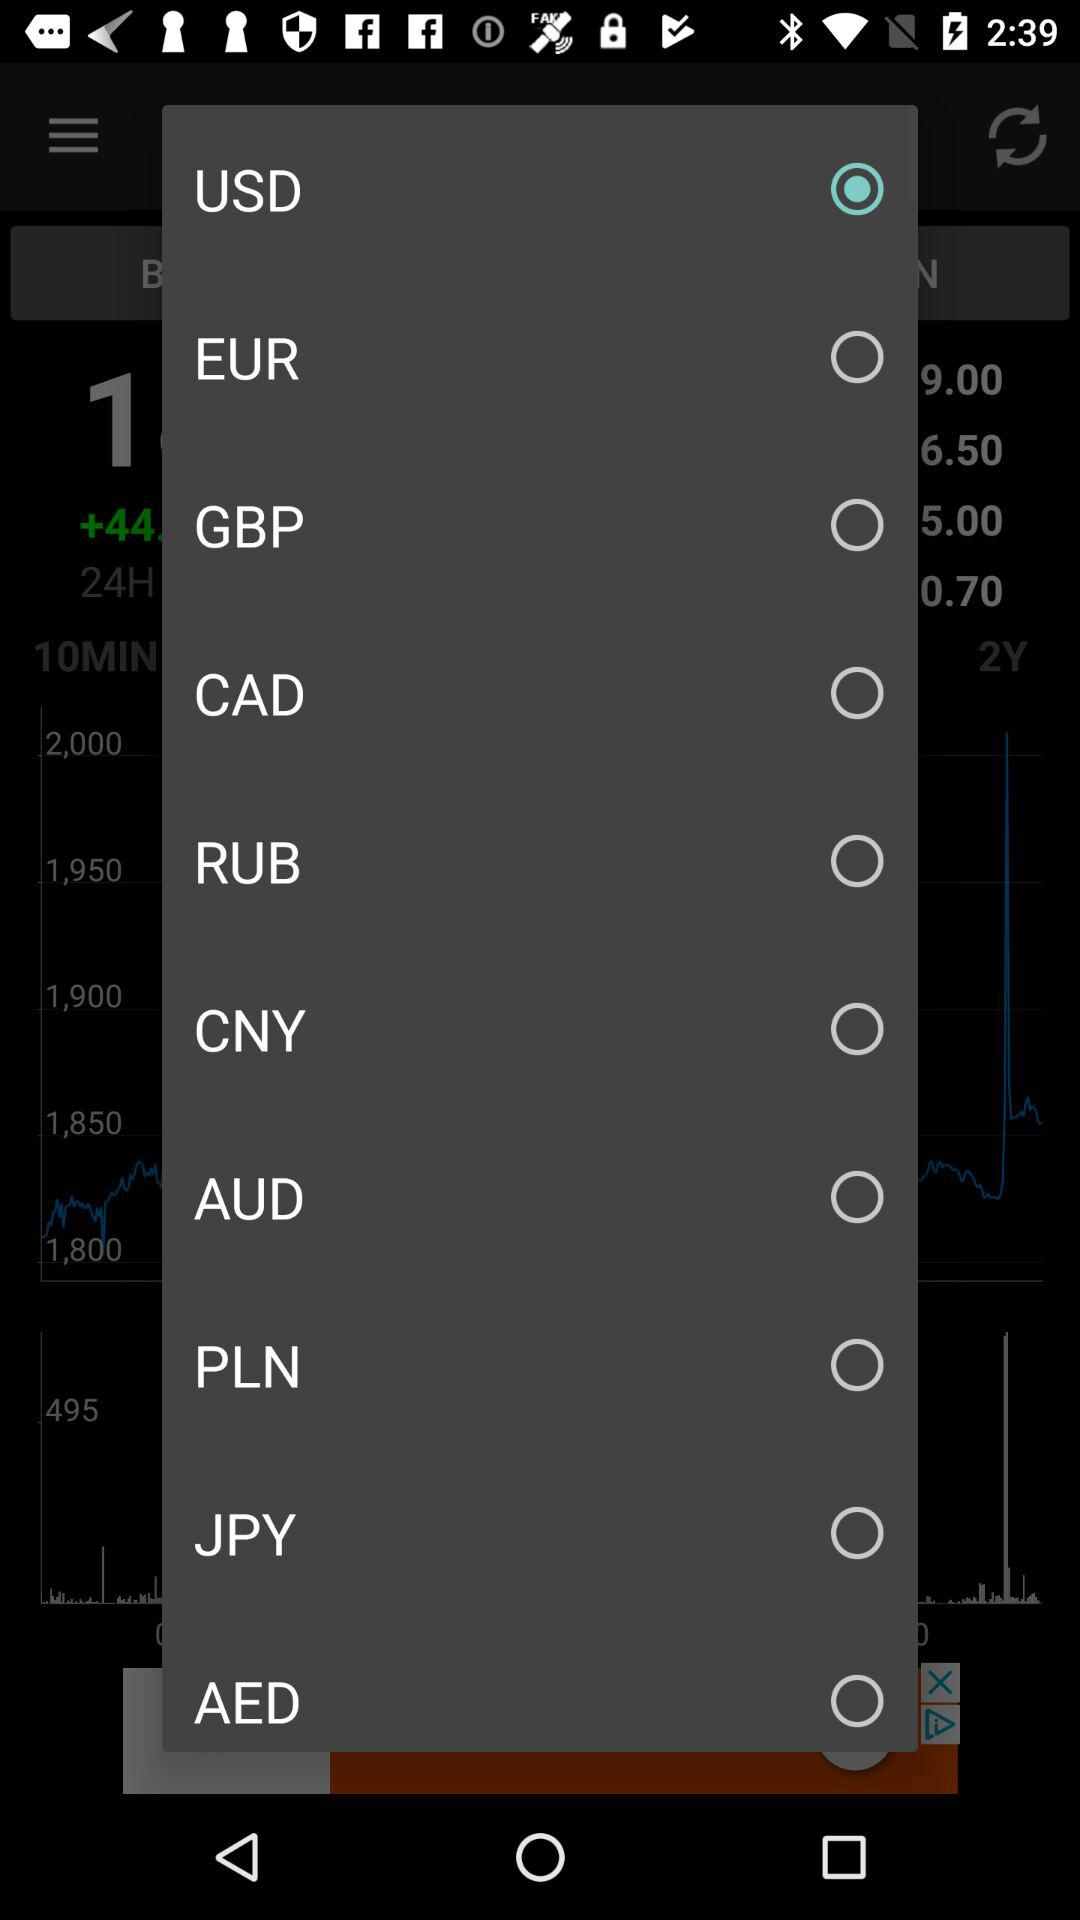What is the selected currency? The selected currency is USD. 